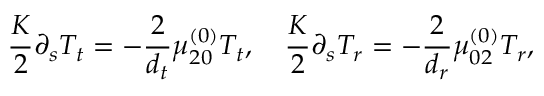Convert formula to latex. <formula><loc_0><loc_0><loc_500><loc_500>\frac { K } { 2 } \partial _ { s } T _ { t } = - \frac { 2 } { { d _ { t } } } \mu _ { 2 0 } ^ { ( 0 ) } T _ { t } , \quad \frac { K } { 2 } \partial _ { s } T _ { r } = - \frac { 2 } { { d _ { r } } } \mu _ { 0 2 } ^ { ( 0 ) } T _ { r } ,</formula> 